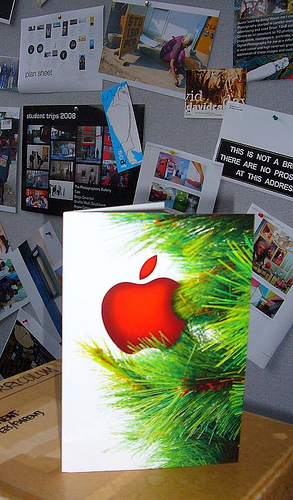<image>
Is the card under the sign? Yes. The card is positioned underneath the sign, with the sign above it in the vertical space. 